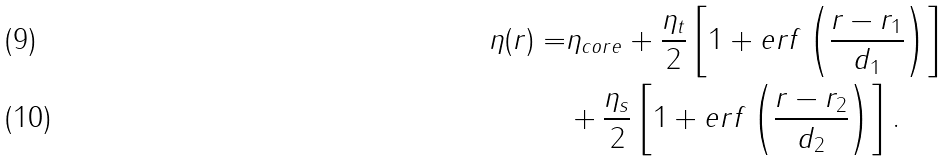<formula> <loc_0><loc_0><loc_500><loc_500>\eta ( r ) = & \eta _ { c o r e } + \frac { \eta _ { t } } { 2 } \left [ 1 + e r f \left ( \frac { r - r _ { 1 } } { d _ { 1 } } \right ) \right ] \\ & + \frac { \eta _ { s } } { 2 } \left [ 1 + e r f \left ( \frac { r - r _ { 2 } } { d _ { 2 } } \right ) \right ] .</formula> 